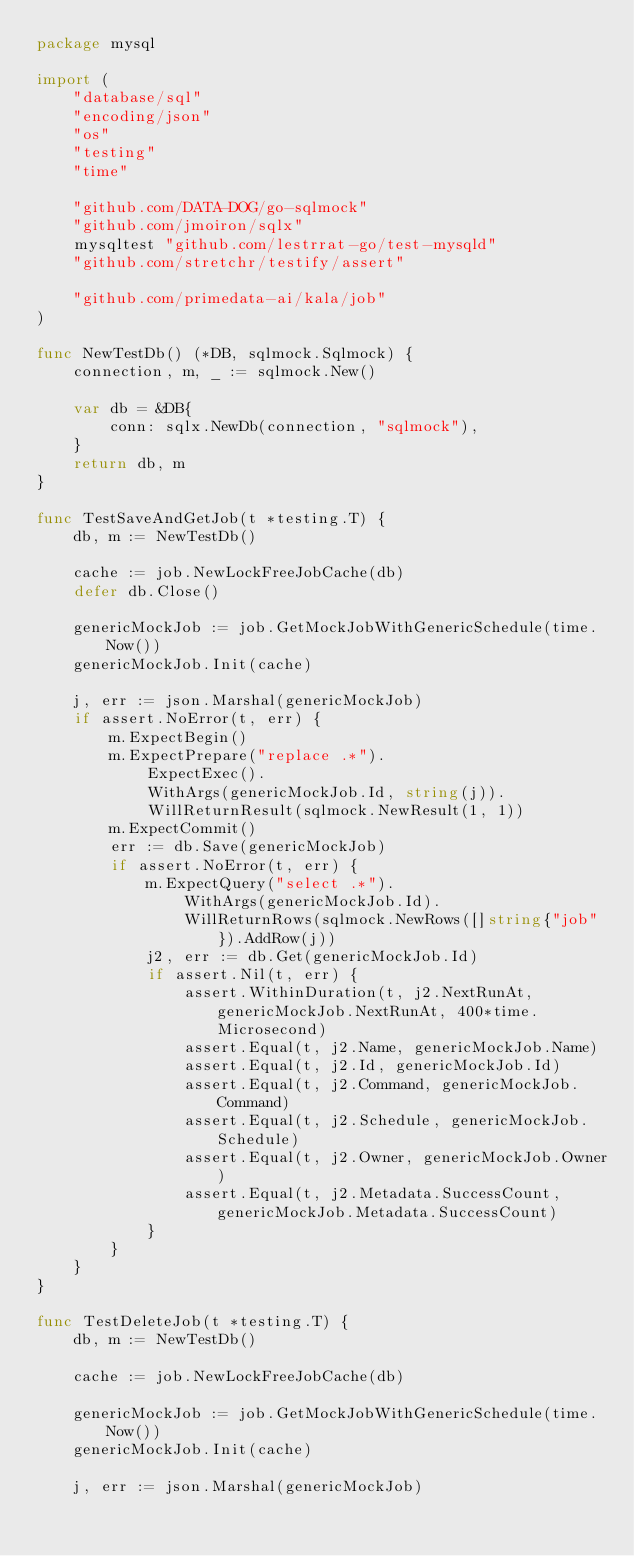<code> <loc_0><loc_0><loc_500><loc_500><_Go_>package mysql

import (
	"database/sql"
	"encoding/json"
	"os"
	"testing"
	"time"

	"github.com/DATA-DOG/go-sqlmock"
	"github.com/jmoiron/sqlx"
	mysqltest "github.com/lestrrat-go/test-mysqld"
	"github.com/stretchr/testify/assert"

	"github.com/primedata-ai/kala/job"
)

func NewTestDb() (*DB, sqlmock.Sqlmock) {
	connection, m, _ := sqlmock.New()

	var db = &DB{
		conn: sqlx.NewDb(connection, "sqlmock"),
	}
	return db, m
}

func TestSaveAndGetJob(t *testing.T) {
	db, m := NewTestDb()

	cache := job.NewLockFreeJobCache(db)
	defer db.Close()

	genericMockJob := job.GetMockJobWithGenericSchedule(time.Now())
	genericMockJob.Init(cache)

	j, err := json.Marshal(genericMockJob)
	if assert.NoError(t, err) {
		m.ExpectBegin()
		m.ExpectPrepare("replace .*").
			ExpectExec().
			WithArgs(genericMockJob.Id, string(j)).
			WillReturnResult(sqlmock.NewResult(1, 1))
		m.ExpectCommit()
		err := db.Save(genericMockJob)
		if assert.NoError(t, err) {
			m.ExpectQuery("select .*").
				WithArgs(genericMockJob.Id).
				WillReturnRows(sqlmock.NewRows([]string{"job"}).AddRow(j))
			j2, err := db.Get(genericMockJob.Id)
			if assert.Nil(t, err) {
				assert.WithinDuration(t, j2.NextRunAt, genericMockJob.NextRunAt, 400*time.Microsecond)
				assert.Equal(t, j2.Name, genericMockJob.Name)
				assert.Equal(t, j2.Id, genericMockJob.Id)
				assert.Equal(t, j2.Command, genericMockJob.Command)
				assert.Equal(t, j2.Schedule, genericMockJob.Schedule)
				assert.Equal(t, j2.Owner, genericMockJob.Owner)
				assert.Equal(t, j2.Metadata.SuccessCount, genericMockJob.Metadata.SuccessCount)
			}
		}
	}
}

func TestDeleteJob(t *testing.T) {
	db, m := NewTestDb()

	cache := job.NewLockFreeJobCache(db)

	genericMockJob := job.GetMockJobWithGenericSchedule(time.Now())
	genericMockJob.Init(cache)

	j, err := json.Marshal(genericMockJob)</code> 